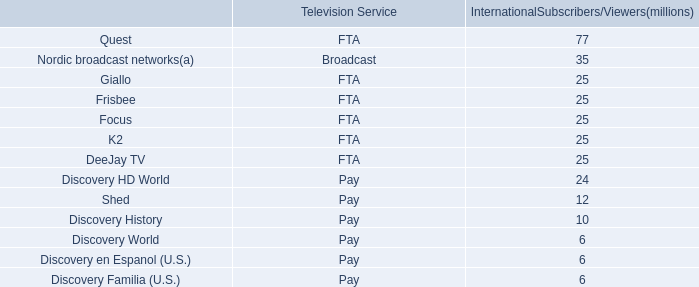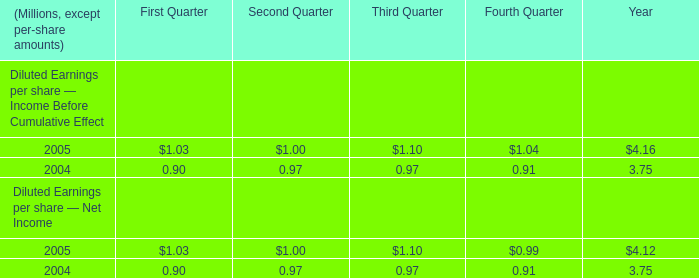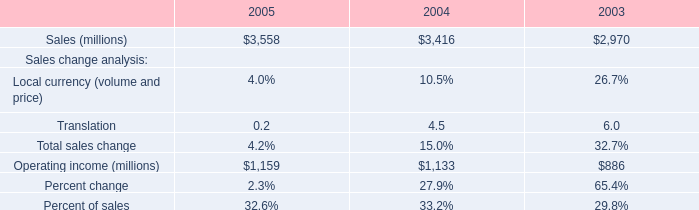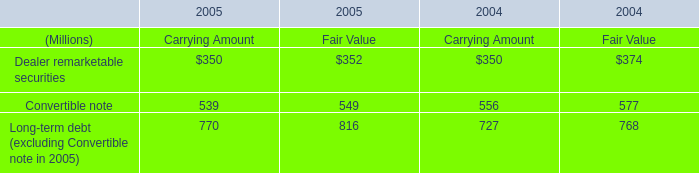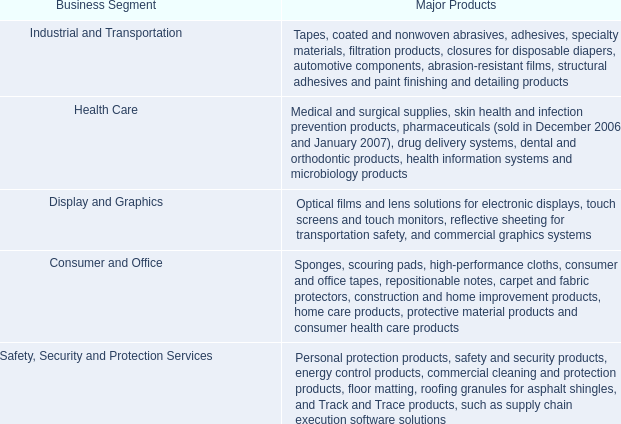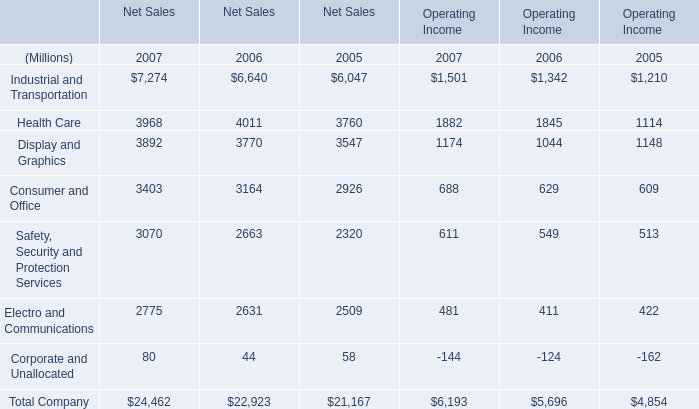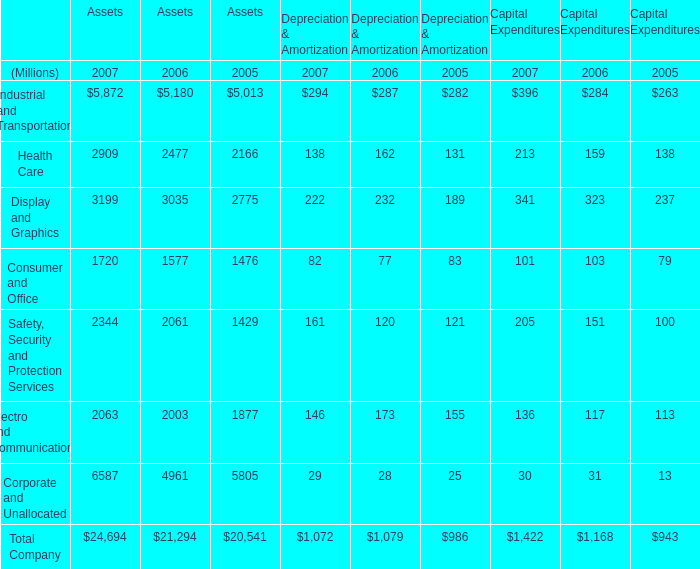In what year is Health Care for Assets greater than 2900? 
Answer: 2007. 